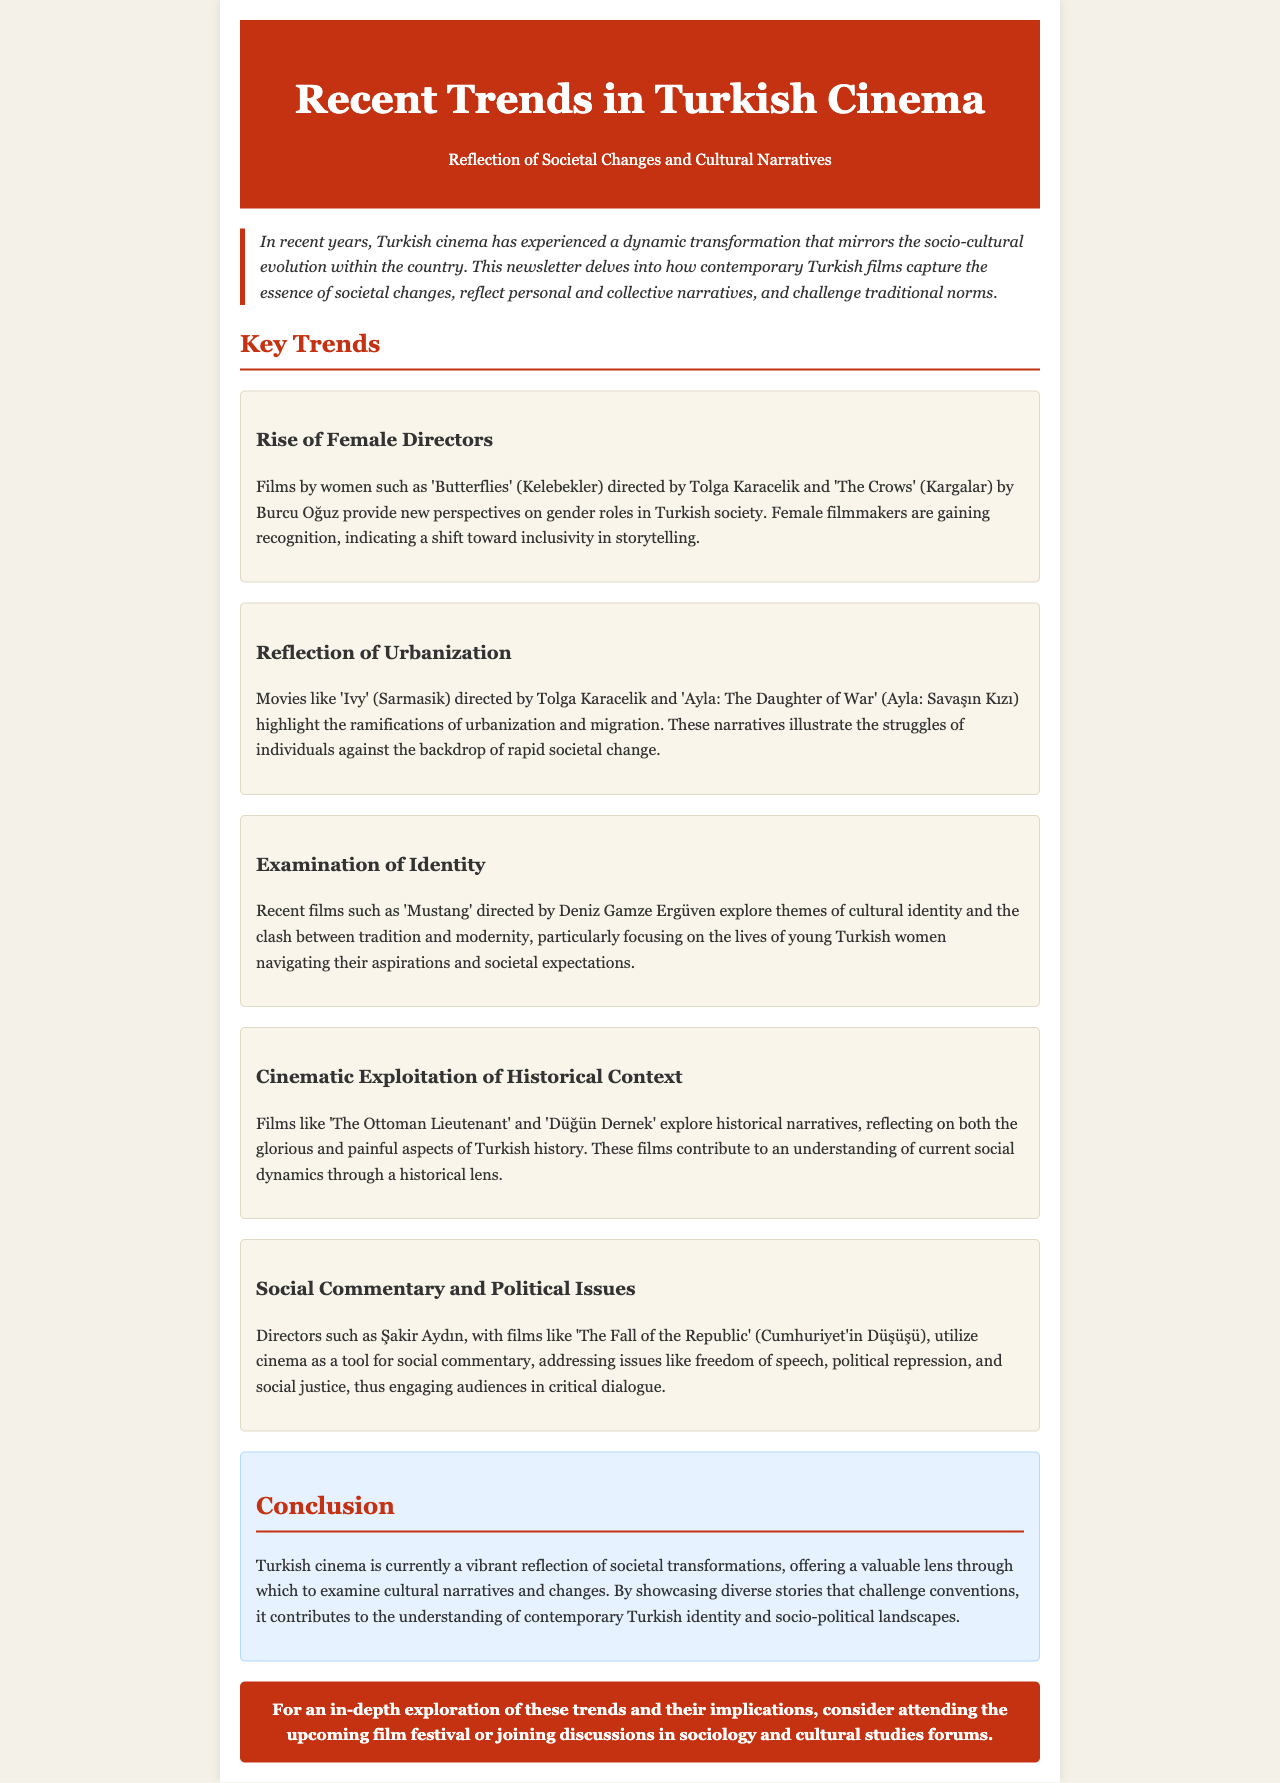What film was directed by Tolga Karacelik that explores gender roles? The film 'Butterflies' (Kelebekler) directed by Tolga Karacelik provides new perspectives on gender roles in Turkish society.
Answer: Butterflies (Kelebekler) What theme is highlighted by the films 'Ivy' and 'Ayla: The Daughter of War'? These films highlight the ramifications of urbanization and migration, illustrating struggles against societal change.
Answer: Urbanization Which element does the film 'Mustang' examine? The film 'Mustang' explores themes of cultural identity and the clash between tradition and modernity.
Answer: Identity What type of issues does Şakir Aydın's film address? Şakir Aydın's film 'The Fall of the Republic' utilizes cinema to address issues like freedom of speech and political repression.
Answer: Political issues What year did the recent transformation in Turkish cinema begin to gain attention? The document notes that this transformation has occurred in recent years, emphasizing a dynamic shift in narratives.
Answer: Recent years What is the overarching conclusion regarding Turkish cinema? The conclusion states that Turkish cinema reflects societal transformations and offers a valuable lens for examining cultural narratives.
Answer: A vibrant reflection of societal transformations 